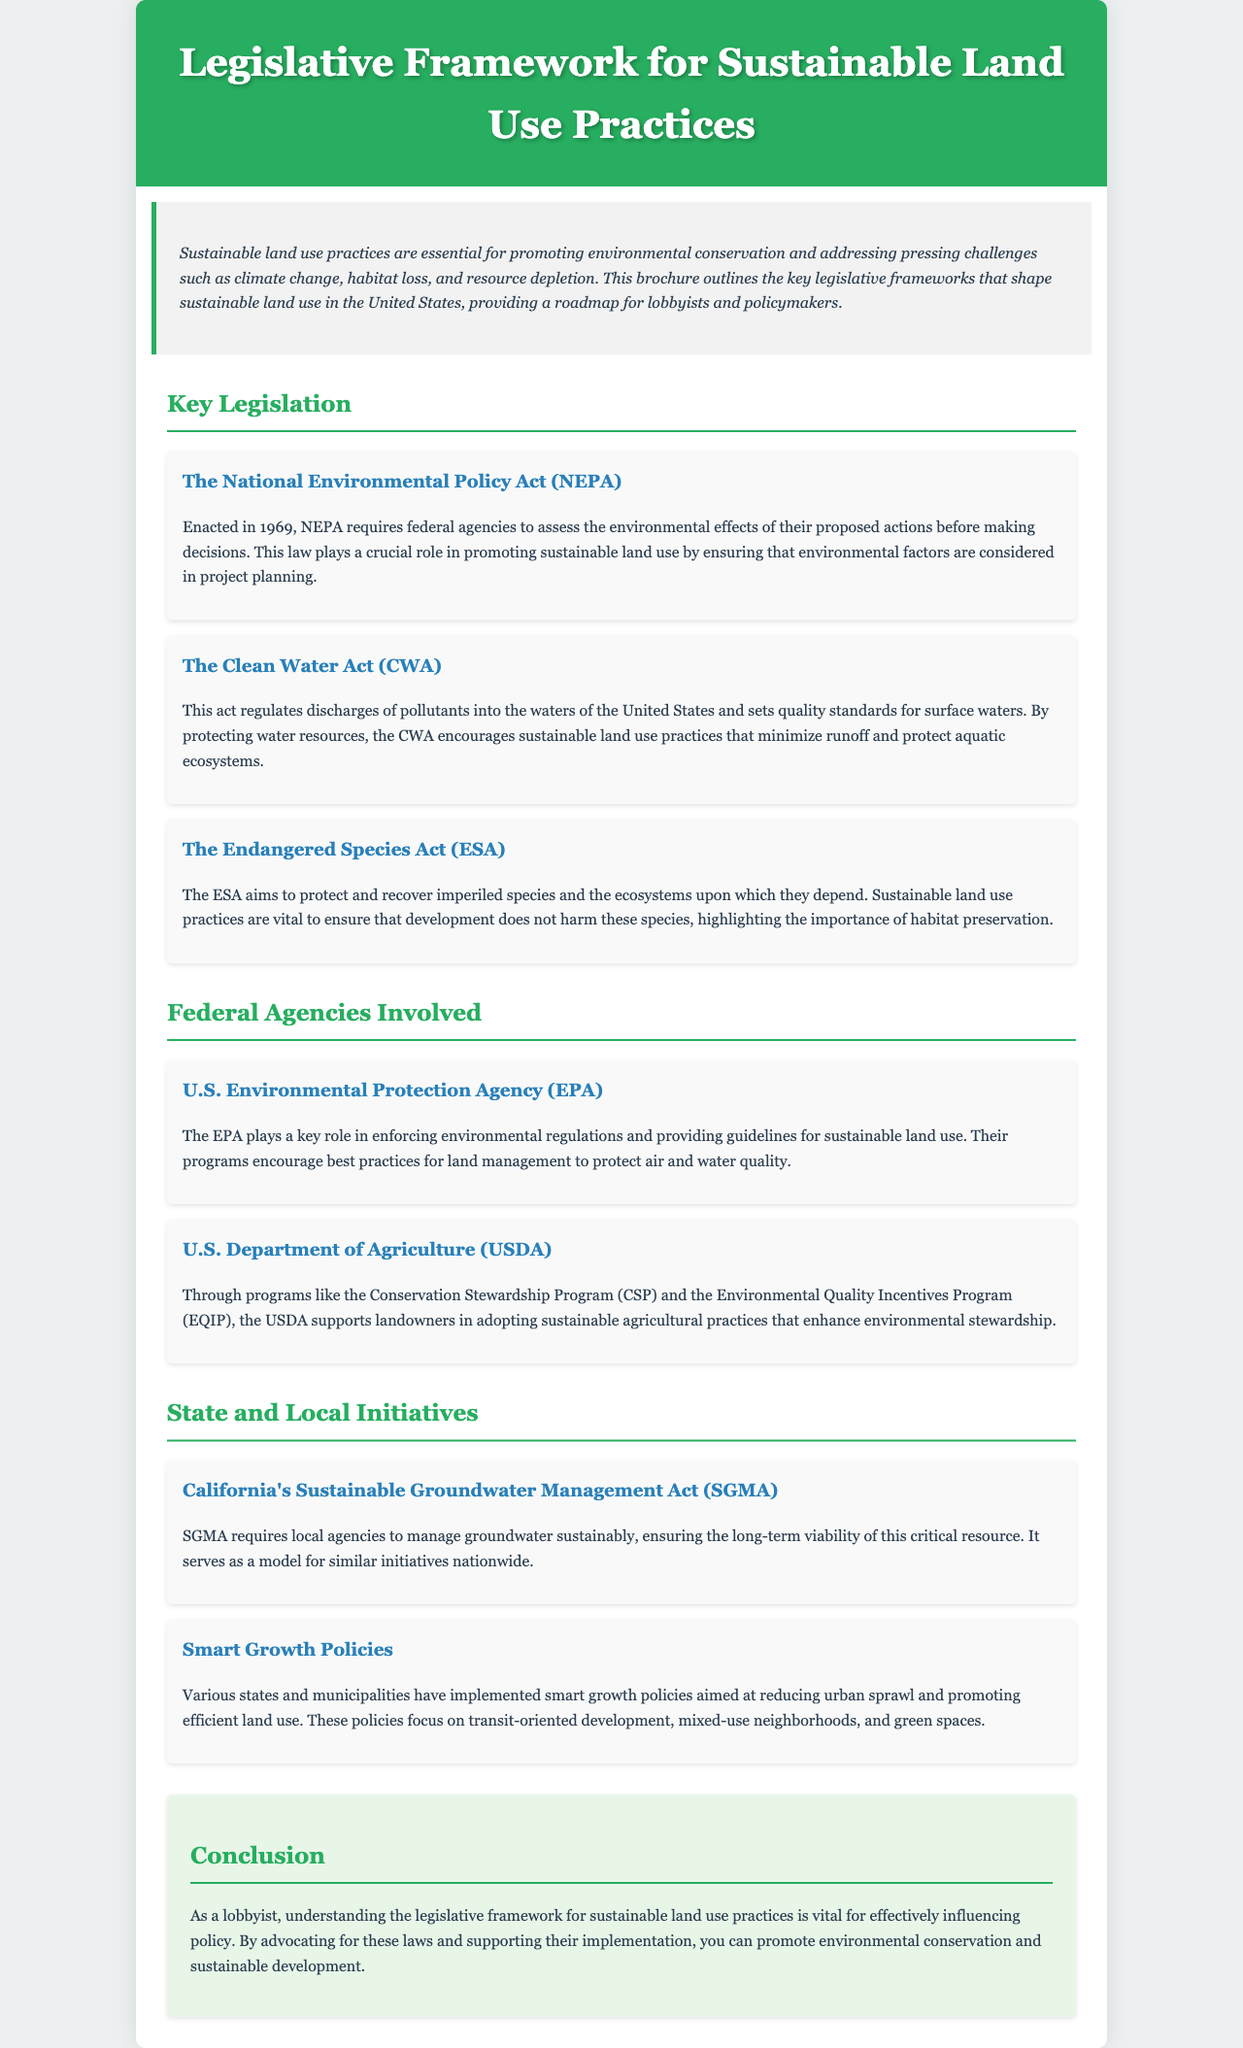What is the main focus of the brochure? The brochure outlines the key legislative frameworks that shape sustainable land use in the United States.
Answer: Key legislative frameworks for sustainable land use What year was the National Environmental Policy Act (NEPA) enacted? NEPA was enacted in 1969.
Answer: 1969 Which federal agency enforces environmental regulations? The EPA plays a key role in enforcing environmental regulations.
Answer: U.S. Environmental Protection Agency (EPA) What is the title of the act that aims to protect imperiled species? The title of the act is the Endangered Species Act (ESA).
Answer: Endangered Species Act (ESA) What initiative does California have for groundwater management? California has the Sustainable Groundwater Management Act (SGMA).
Answer: Sustainable Groundwater Management Act (SGMA) Which programs does the USDA offer to support sustainable agricultural practices? The USDA offers the Conservation Stewardship Program (CSP) and Environmental Quality Incentives Program (EQIP).
Answer: CSP and EQIP What type of policies focus on reducing urban sprawl? Smart growth policies aim to reduce urban sprawl.
Answer: Smart growth policies How does the Clean Water Act (CWA) contribute to sustainable land use? The CWA encourages sustainable land use practices that minimize runoff and protect aquatic ecosystems.
Answer: By protecting water resources What key role does the USDA play in environmental stewardship? The USDA supports landowners in adopting sustainable agricultural practices.
Answer: Supports landowners in adopting sustainable practices What is the overall conclusion regarding the role of lobbyists? Understanding the legislative framework is vital for effectively influencing policy.
Answer: Vital for effectively influencing policy 